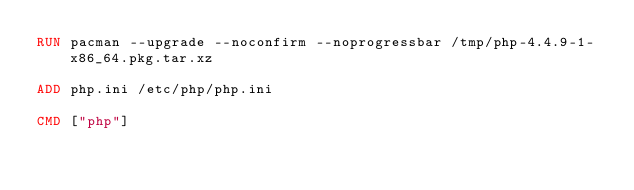<code> <loc_0><loc_0><loc_500><loc_500><_Dockerfile_>RUN pacman --upgrade --noconfirm --noprogressbar /tmp/php-4.4.9-1-x86_64.pkg.tar.xz

ADD php.ini /etc/php/php.ini

CMD ["php"]
</code> 